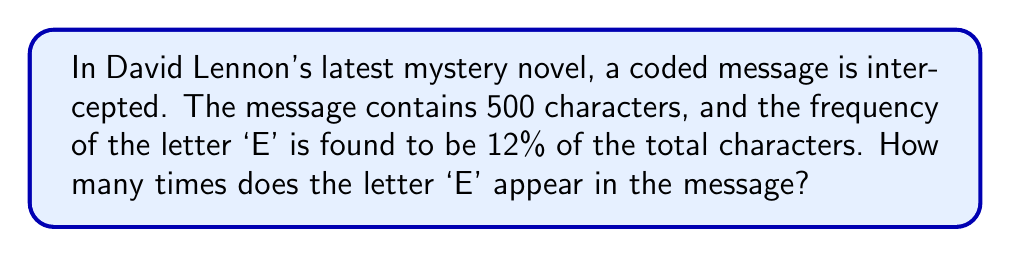Can you answer this question? To solve this problem, we need to follow these steps:

1. Understand the given information:
   - Total number of characters in the message: 500
   - Frequency of the letter 'E': 12% of total characters

2. Convert the percentage to a decimal:
   $12\% = \frac{12}{100} = 0.12$

3. Calculate the number of times 'E' appears:
   Let $x$ be the number of times 'E' appears.
   $$x = 500 \times 0.12$$

4. Perform the multiplication:
   $$x = 500 \times 0.12 = 60$$

Therefore, the letter 'E' appears 60 times in the coded message.
Answer: 60 